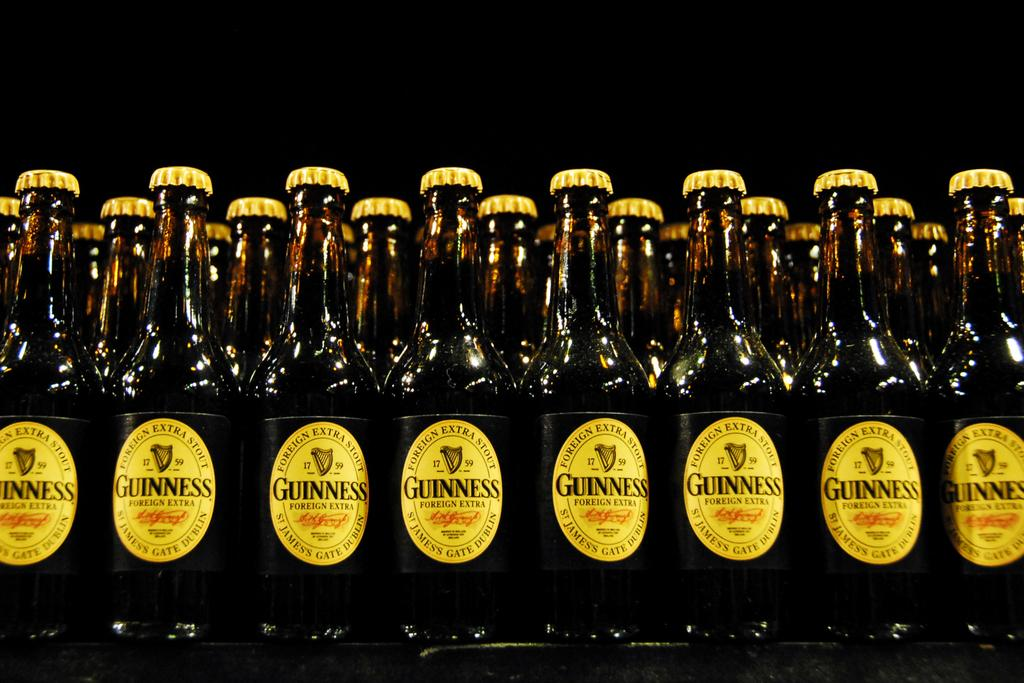<image>
Give a short and clear explanation of the subsequent image. Several bottles of Guinness Ale sit on display in a store 